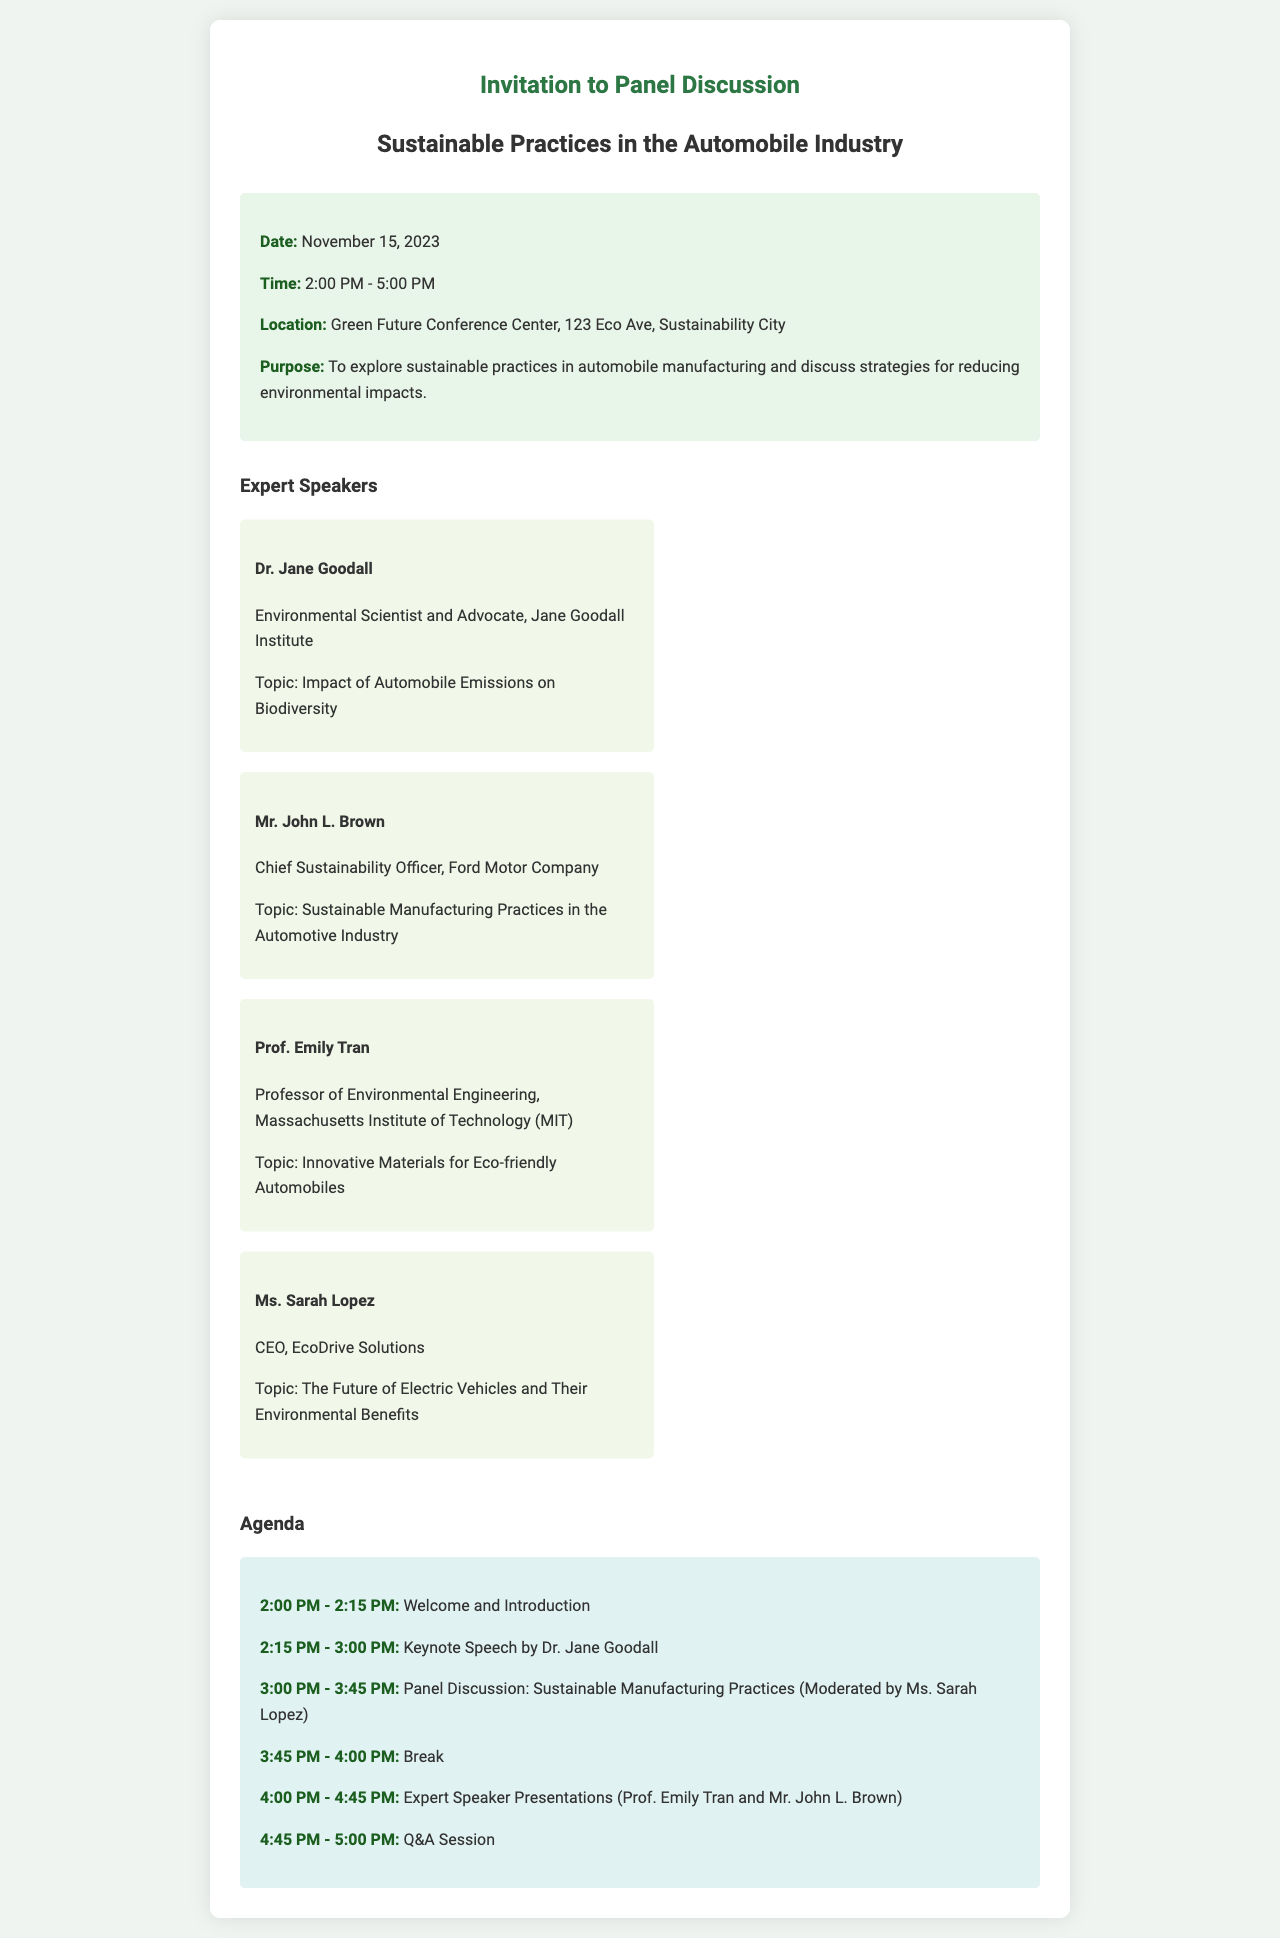What is the date of the event? The document states that the event is scheduled for November 15, 2023.
Answer: November 15, 2023 What time does the panel discussion start? The event details indicate that the panel discussion starts at 2:00 PM.
Answer: 2:00 PM Who is the CEO of EcoDrive Solutions? The document lists Ms. Sarah Lopez as the CEO of EcoDrive Solutions.
Answer: Ms. Sarah Lopez What is the duration of the break? The agenda specifies that there is a break from 3:45 PM to 4:00 PM, which is 15 minutes.
Answer: 15 minutes What topic will Dr. Jane Goodall discuss? The document mentions that Dr. Jane Goodall will discuss the impact of automobile emissions on biodiversity.
Answer: Impact of Automobile Emissions on Biodiversity How many expert speakers are listed in the document? The section on expert speakers includes a total of four individuals.
Answer: Four What is one of the purposes of the event? The document states that a purpose of the event is to explore sustainable practices in automobile manufacturing.
Answer: Explore sustainable practices What will happen during the Q&A session? The agenda specifies that there will be a Q&A session, allowing attendees to ask questions and interact.
Answer: Q&A Session Who is moderating the panel discussion? The agenda indicates that Ms. Sarah Lopez will moderate the panel discussion on sustainable manufacturing practices.
Answer: Ms. Sarah Lopez 